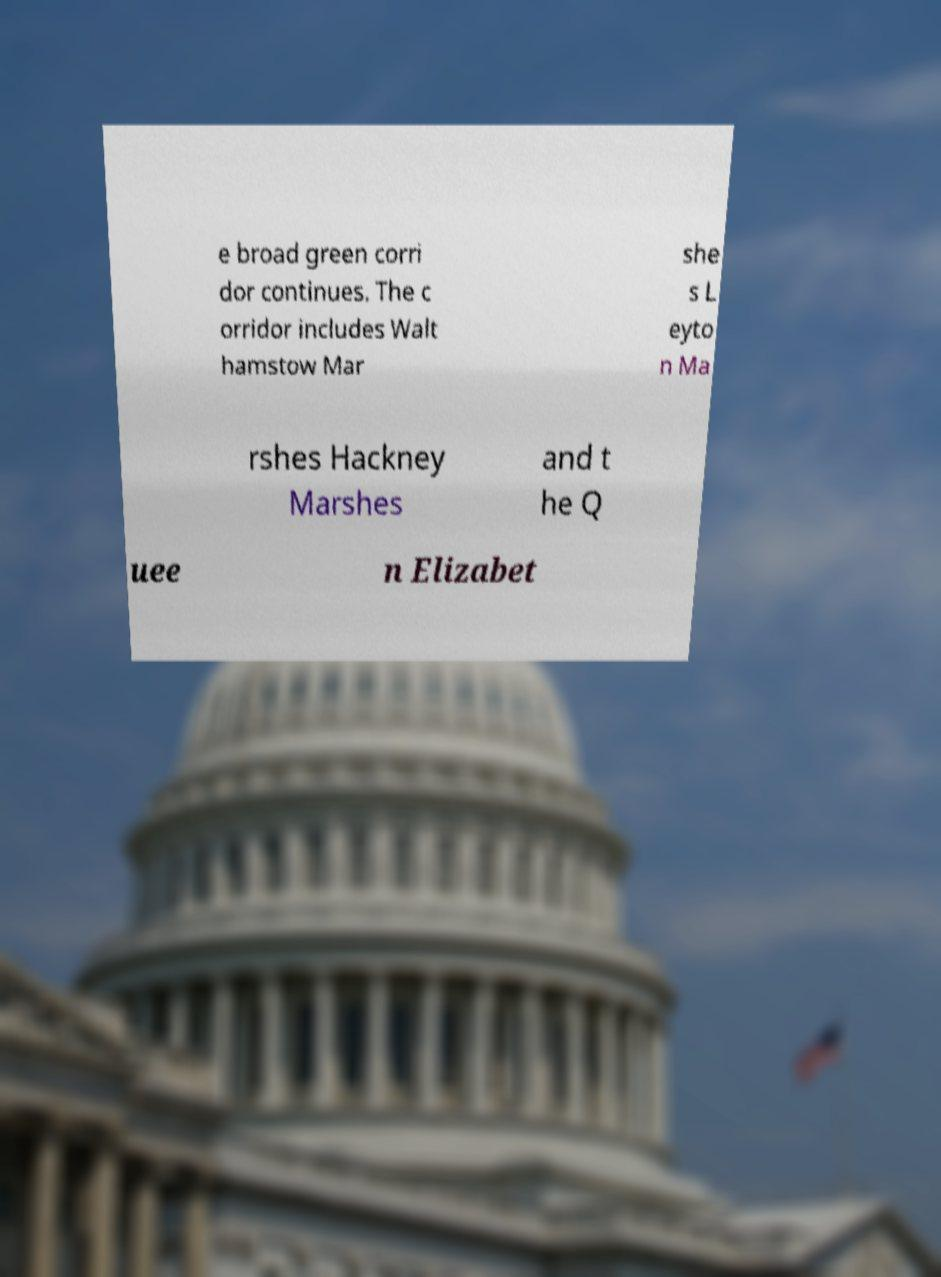For documentation purposes, I need the text within this image transcribed. Could you provide that? e broad green corri dor continues. The c orridor includes Walt hamstow Mar she s L eyto n Ma rshes Hackney Marshes and t he Q uee n Elizabet 